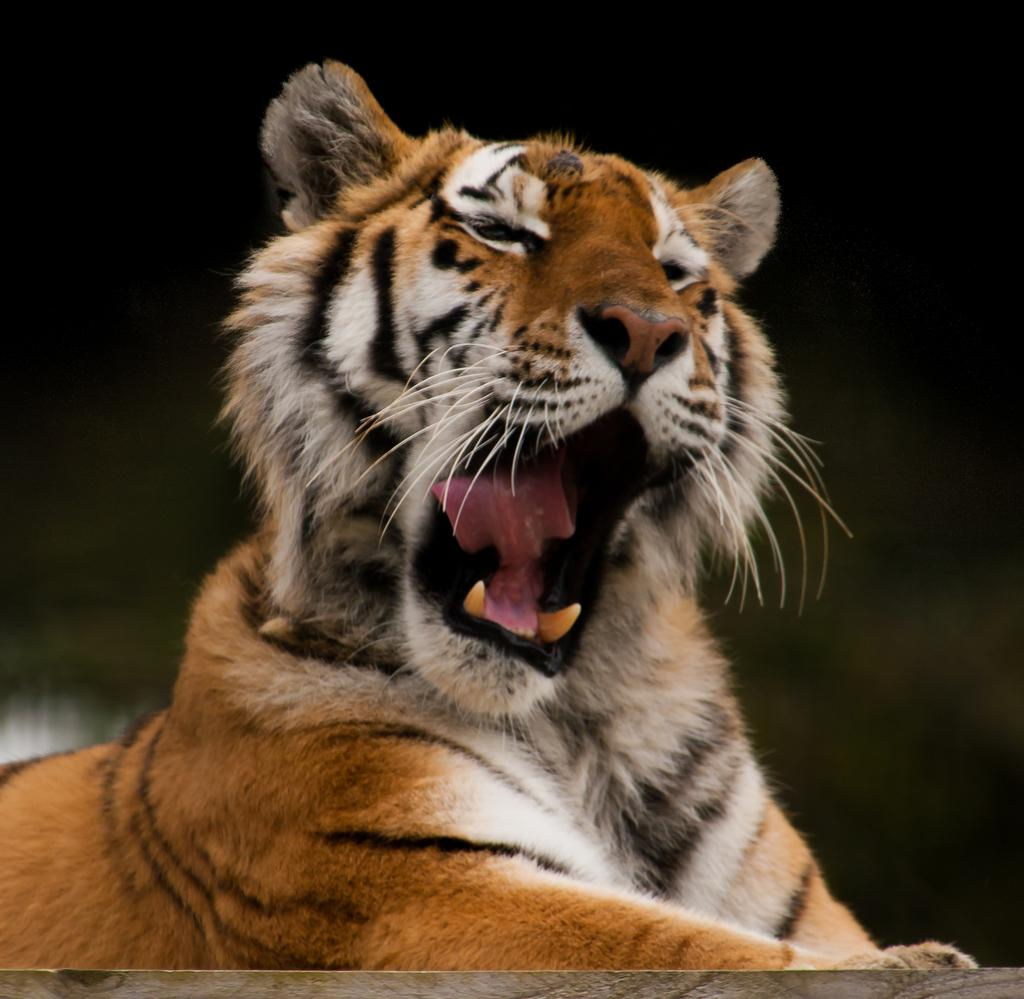What animal is the main subject of the image? There is a tiger in the image. What is the tiger doing in the image? The tiger is opening its mouth wide. Can you describe the background of the image? The background of the tiger is blurred. What type of health advice can be seen in the image? There is no health advice present in the image; it features a tiger opening its mouth wide with a blurred background. How many eggs are visible in the image? There are no eggs present in the image. 